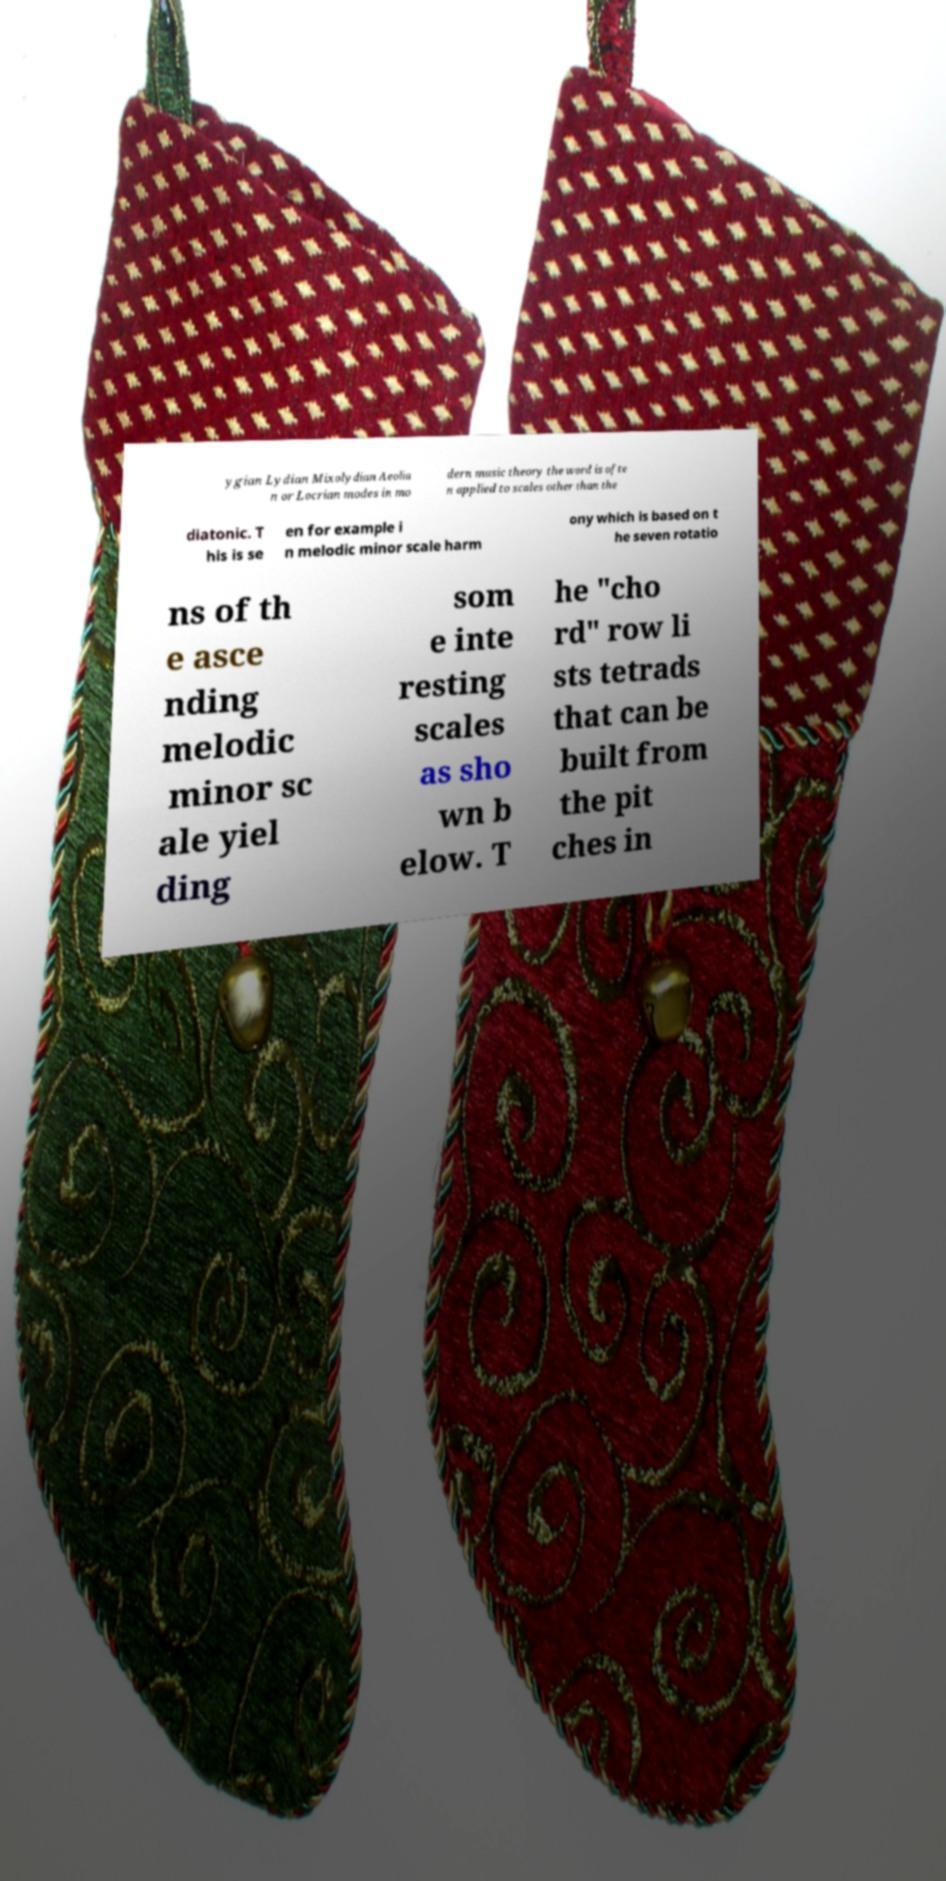Could you extract and type out the text from this image? ygian Lydian Mixolydian Aeolia n or Locrian modes in mo dern music theory the word is ofte n applied to scales other than the diatonic. T his is se en for example i n melodic minor scale harm ony which is based on t he seven rotatio ns of th e asce nding melodic minor sc ale yiel ding som e inte resting scales as sho wn b elow. T he "cho rd" row li sts tetrads that can be built from the pit ches in 